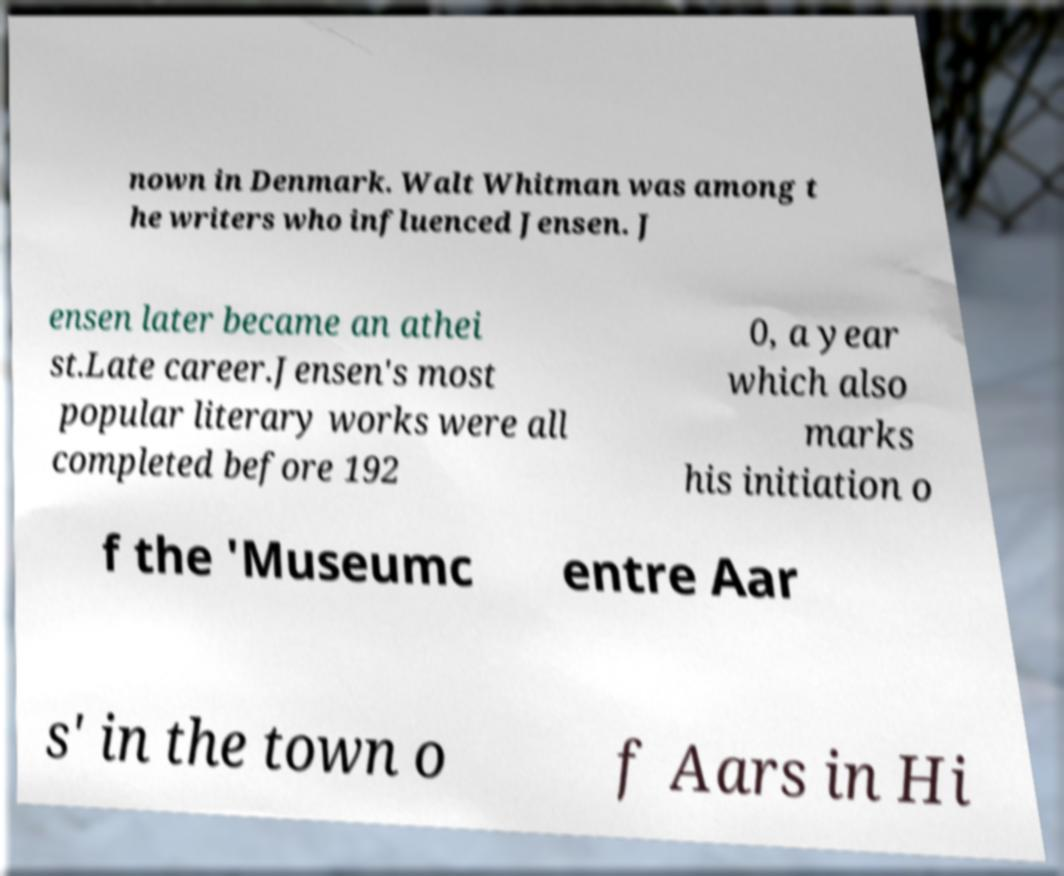Can you read and provide the text displayed in the image?This photo seems to have some interesting text. Can you extract and type it out for me? nown in Denmark. Walt Whitman was among t he writers who influenced Jensen. J ensen later became an athei st.Late career.Jensen's most popular literary works were all completed before 192 0, a year which also marks his initiation o f the 'Museumc entre Aar s' in the town o f Aars in Hi 